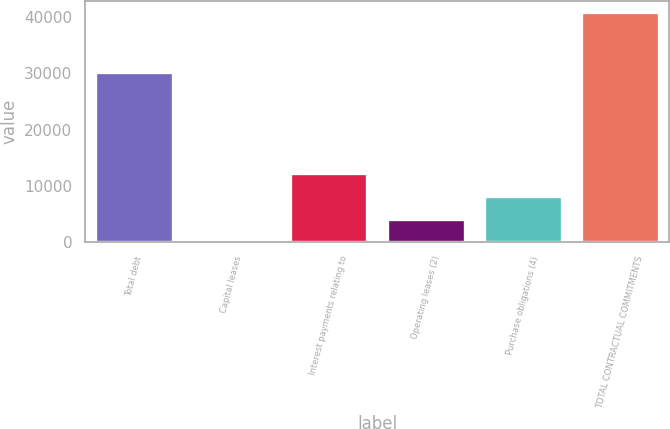Convert chart to OTSL. <chart><loc_0><loc_0><loc_500><loc_500><bar_chart><fcel>Total debt<fcel>Capital leases<fcel>Interest payments relating to<fcel>Operating leases (2)<fcel>Purchase obligations (4)<fcel>TOTAL CONTRACTUAL COMMITMENTS<nl><fcel>30221<fcel>45<fcel>12316.2<fcel>4135.4<fcel>8225.8<fcel>40949<nl></chart> 